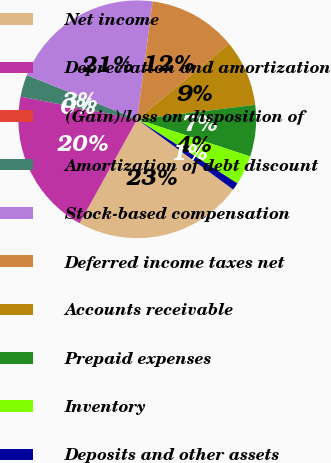Convert chart to OTSL. <chart><loc_0><loc_0><loc_500><loc_500><pie_chart><fcel>Net income<fcel>Depreciation and amortization<fcel>(Gain)/loss on disposition of<fcel>Amortization of debt discount<fcel>Stock-based compensation<fcel>Deferred income taxes net<fcel>Accounts receivable<fcel>Prepaid expenses<fcel>Inventory<fcel>Deposits and other assets<nl><fcel>23.0%<fcel>20.0%<fcel>0.0%<fcel>3.0%<fcel>21.0%<fcel>12.0%<fcel>9.0%<fcel>7.0%<fcel>4.0%<fcel>1.0%<nl></chart> 